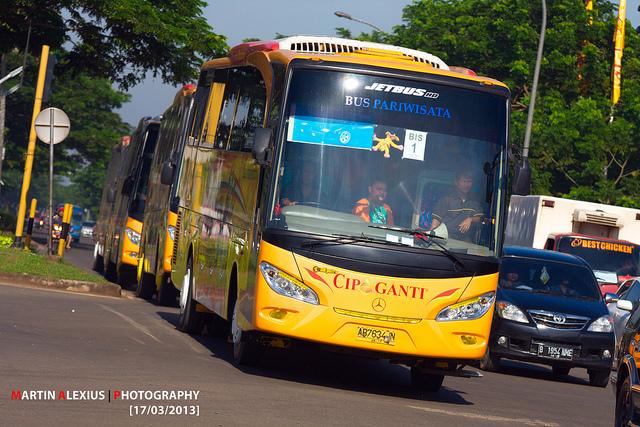How many buses are in a row?
Give a very brief answer. 3. Is this a "JetBus"?
Quick response, please. Yes. Is this a city bus?
Short answer required. Yes. Does the street look busy?
Short answer required. Yes. 